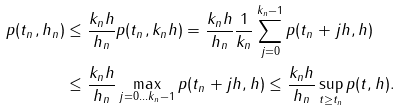<formula> <loc_0><loc_0><loc_500><loc_500>p ( t _ { n } , h _ { n } ) & \leq \frac { k _ { n } h } { h _ { n } } p ( t _ { n } , k _ { n } h ) = \frac { k _ { n } h } { h _ { n } } \frac { 1 } { k _ { n } } \sum _ { j = 0 } ^ { k _ { n } - 1 } p ( t _ { n } + j h , h ) \\ & \leq \frac { k _ { n } h } { h _ { n } } \max _ { j = 0 \dots k _ { n } - 1 } p ( t _ { n } + j h , h ) \leq \frac { k _ { n } h } { h _ { n } } \sup _ { t \geq t _ { n } } p ( t , h ) .</formula> 